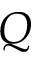Convert formula to latex. <formula><loc_0><loc_0><loc_500><loc_500>Q</formula> 